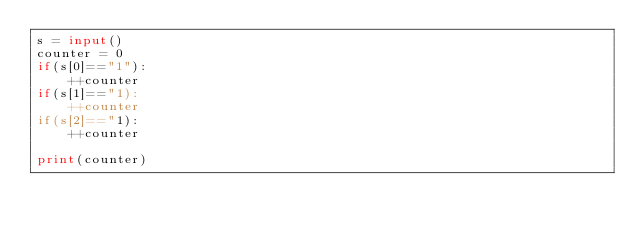<code> <loc_0><loc_0><loc_500><loc_500><_Python_>s = input()
counter = 0
if(s[0]=="1"):
    ++counter
if(s[1]=="1):
    ++counter
if(s[2]=="1):
    ++counter

print(counter)
</code> 